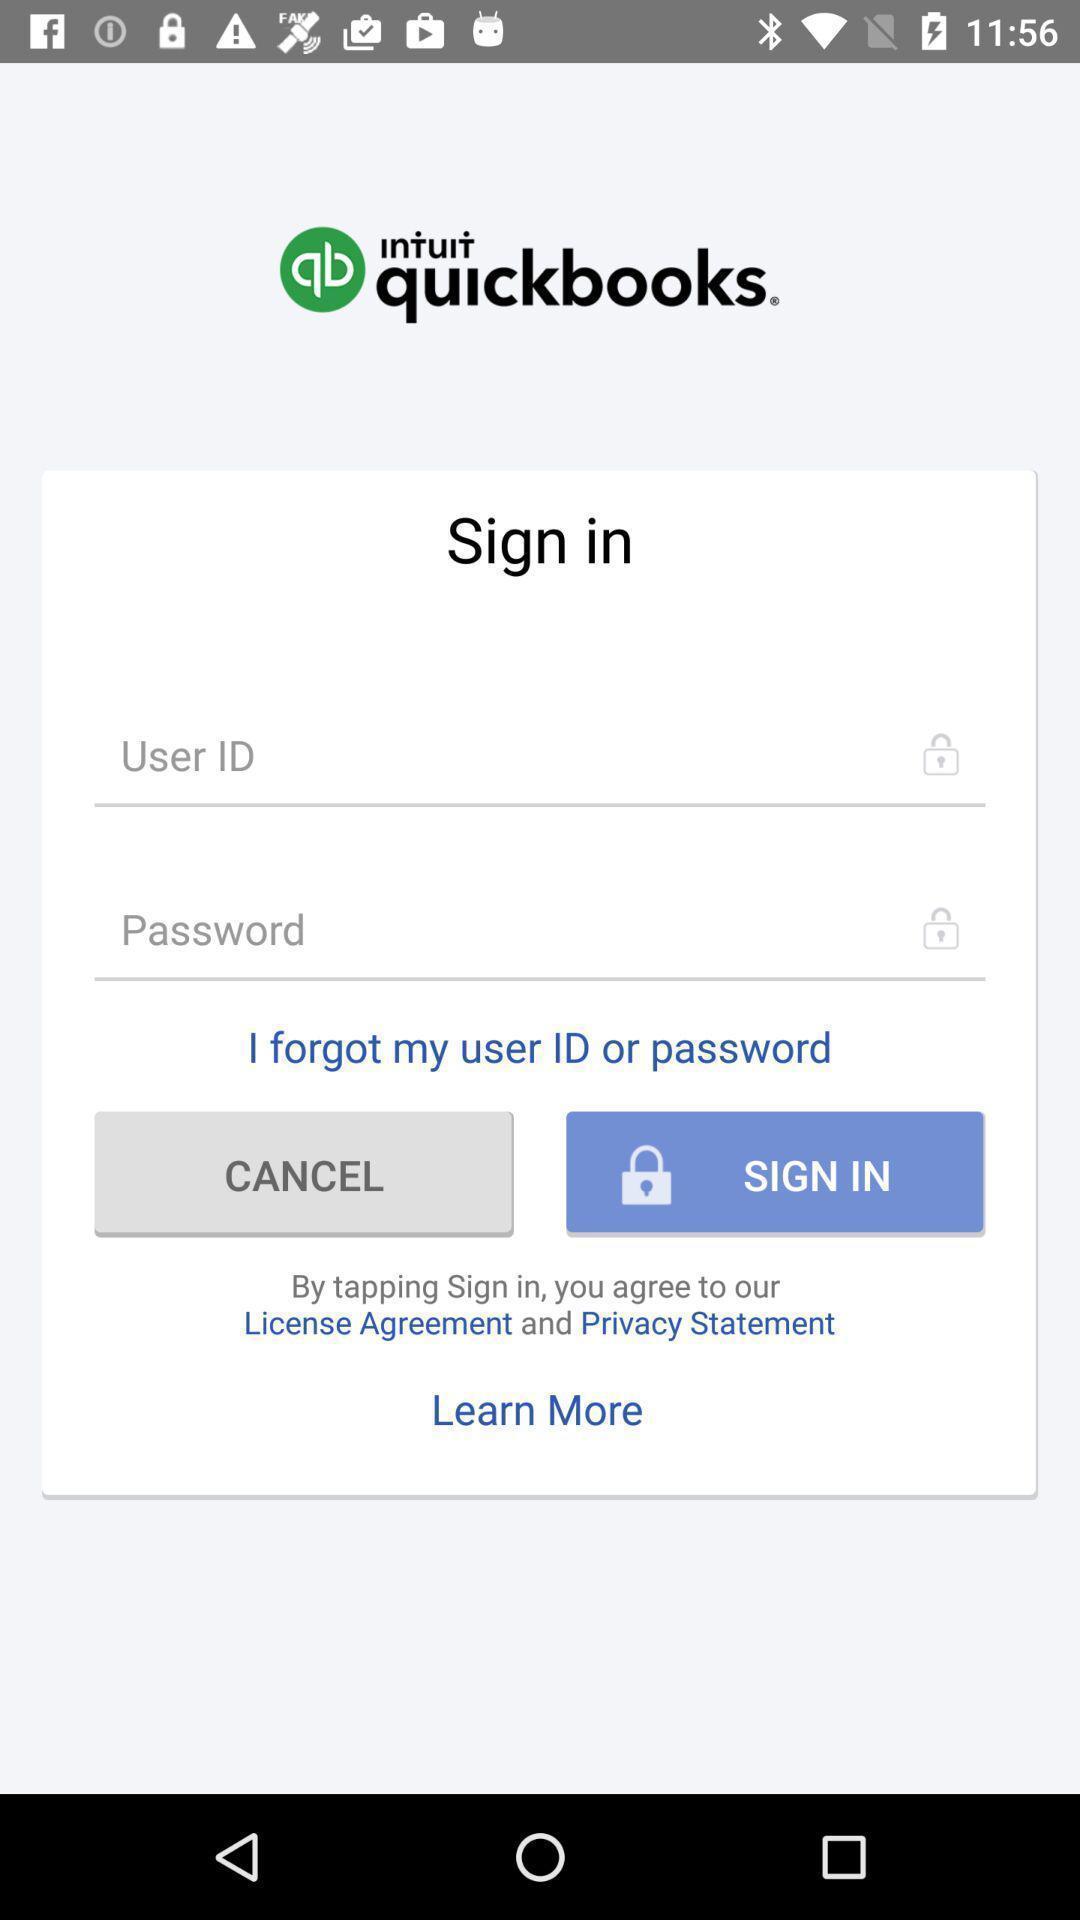Describe the key features of this screenshot. Sign in page. 